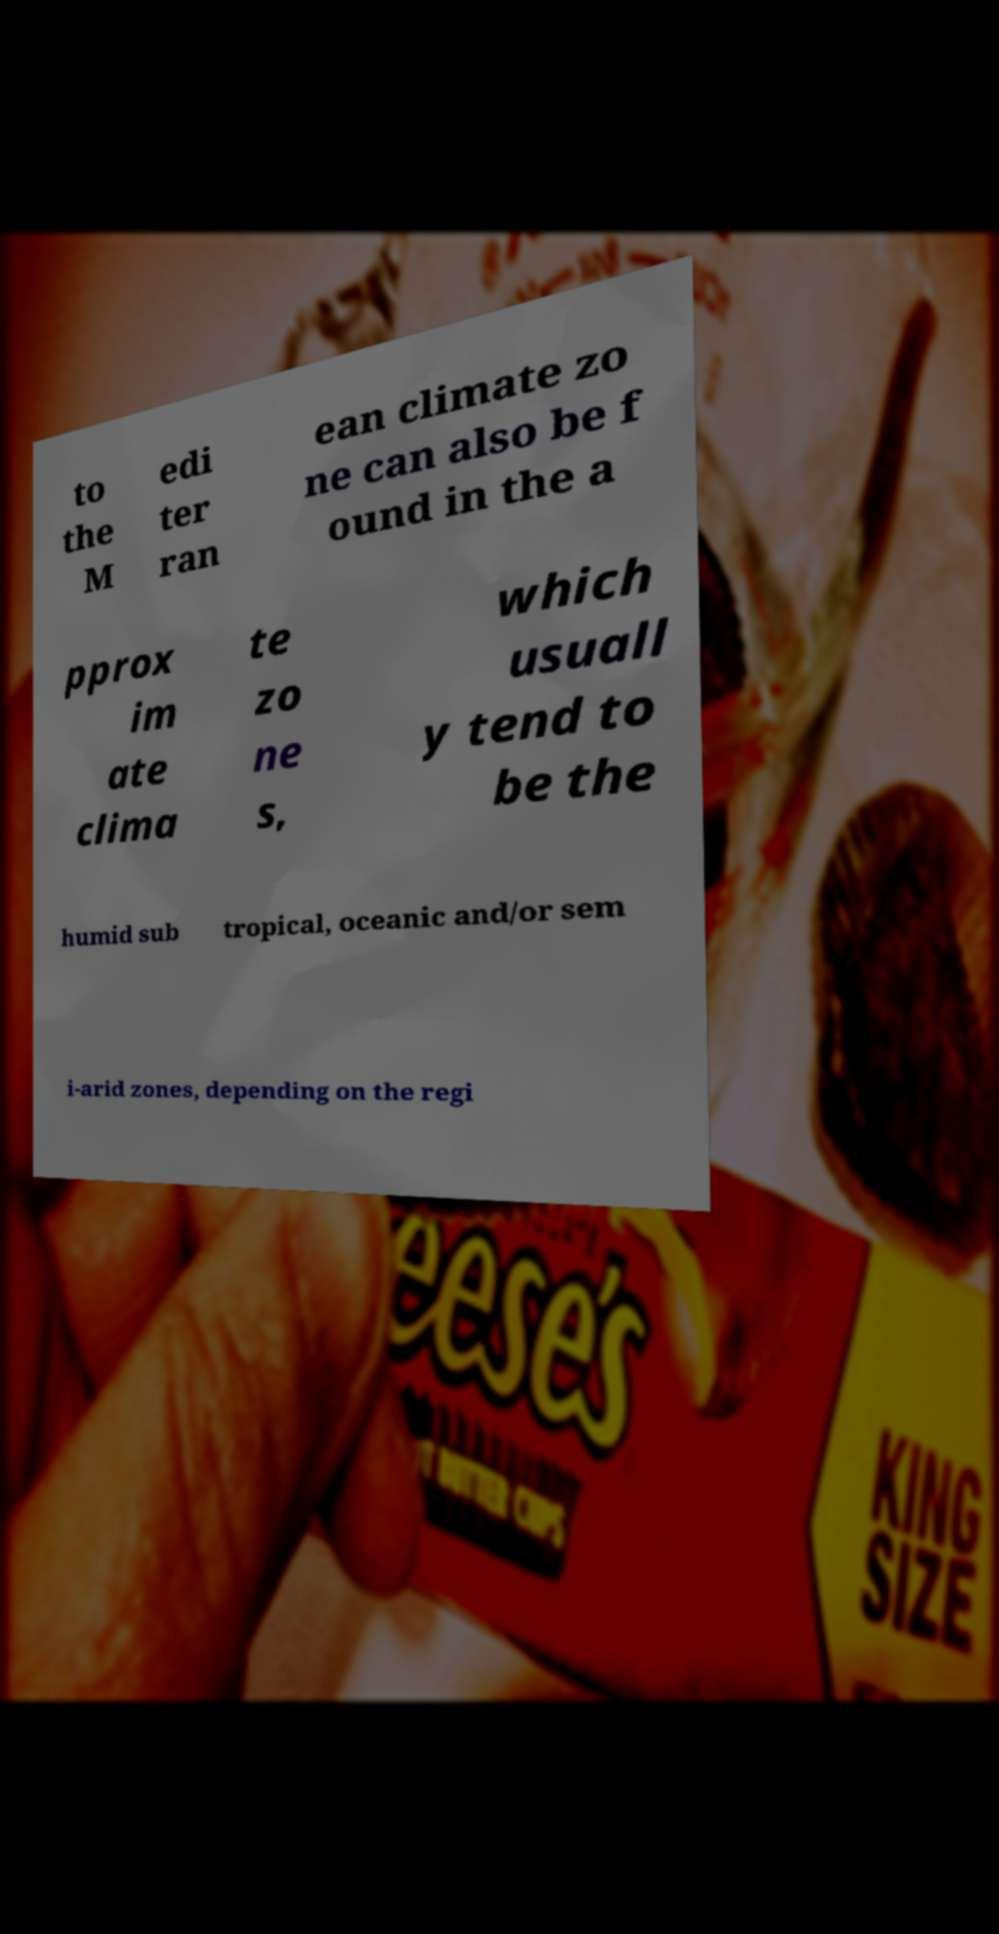There's text embedded in this image that I need extracted. Can you transcribe it verbatim? to the M edi ter ran ean climate zo ne can also be f ound in the a pprox im ate clima te zo ne s, which usuall y tend to be the humid sub tropical, oceanic and/or sem i-arid zones, depending on the regi 